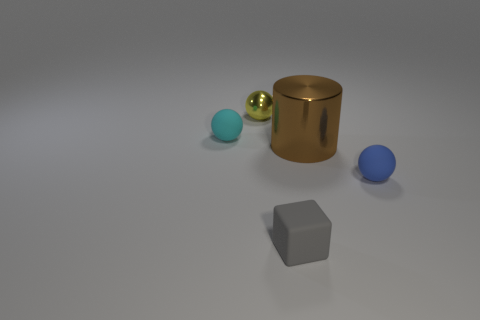There is a brown cylinder that is the same material as the yellow sphere; what is its size?
Offer a very short reply. Large. Are there more metal balls that are left of the tiny yellow sphere than yellow balls?
Ensure brevity in your answer.  No. There is a thing that is both on the right side of the yellow object and behind the blue thing; what is its size?
Your answer should be very brief. Large. There is a cyan thing that is the same shape as the yellow metallic object; what is its material?
Your response must be concise. Rubber. There is a rubber sphere behind the brown thing; is its size the same as the tiny yellow sphere?
Provide a short and direct response. Yes. There is a thing that is to the right of the cyan rubber thing and on the left side of the small rubber cube; what color is it?
Keep it short and to the point. Yellow. There is a matte ball on the right side of the small gray rubber thing; how many large metal cylinders are on the right side of it?
Make the answer very short. 0. Do the cyan rubber object and the brown shiny object have the same shape?
Provide a succinct answer. No. Is there any other thing of the same color as the big cylinder?
Your answer should be very brief. No. There is a gray thing; does it have the same shape as the small matte thing behind the large brown shiny thing?
Make the answer very short. No. 